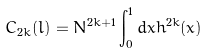<formula> <loc_0><loc_0><loc_500><loc_500>C _ { 2 k } ( { \bar { l } } ) = N ^ { 2 k + 1 } \int _ { 0 } ^ { 1 } d x { \bar { h } } ^ { 2 k } ( x )</formula> 